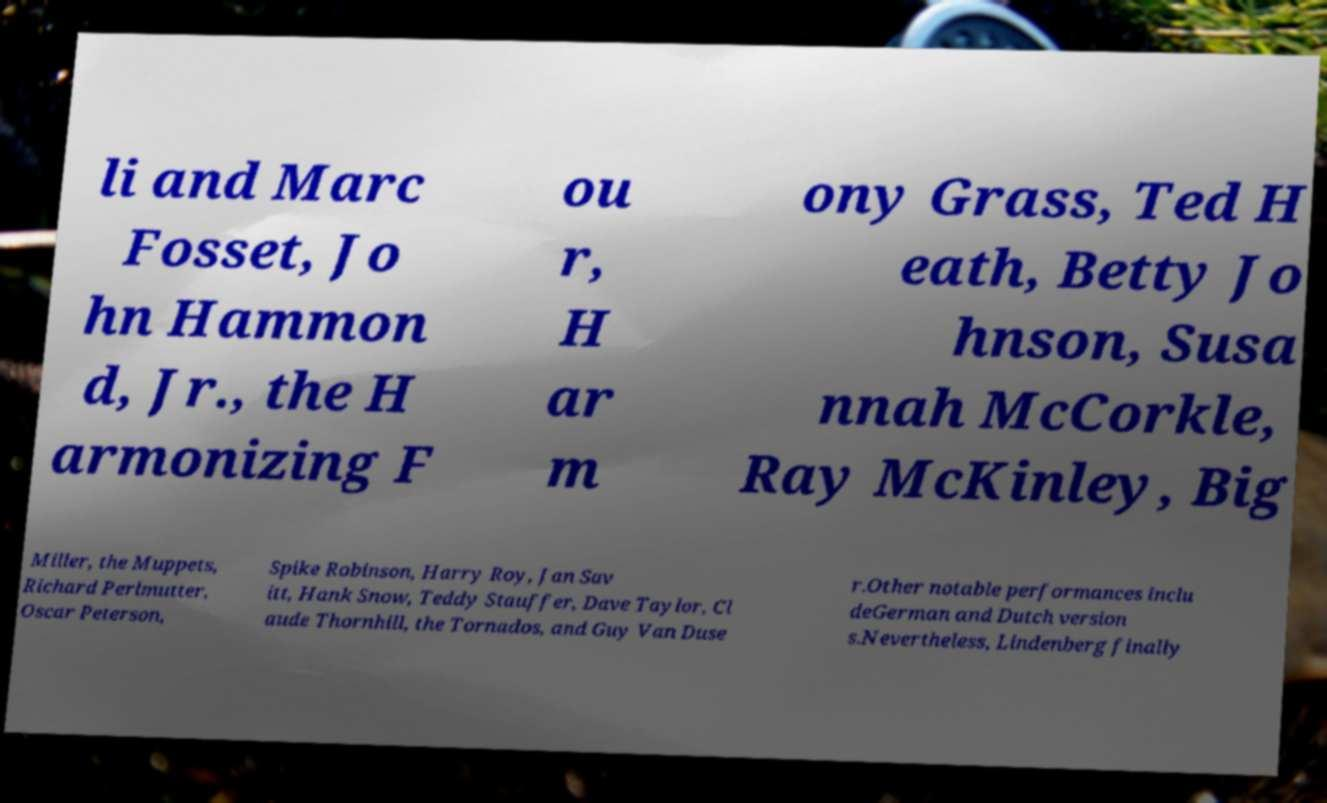Could you assist in decoding the text presented in this image and type it out clearly? li and Marc Fosset, Jo hn Hammon d, Jr., the H armonizing F ou r, H ar m ony Grass, Ted H eath, Betty Jo hnson, Susa nnah McCorkle, Ray McKinley, Big Miller, the Muppets, Richard Perlmutter, Oscar Peterson, Spike Robinson, Harry Roy, Jan Sav itt, Hank Snow, Teddy Stauffer, Dave Taylor, Cl aude Thornhill, the Tornados, and Guy Van Duse r.Other notable performances inclu deGerman and Dutch version s.Nevertheless, Lindenberg finally 